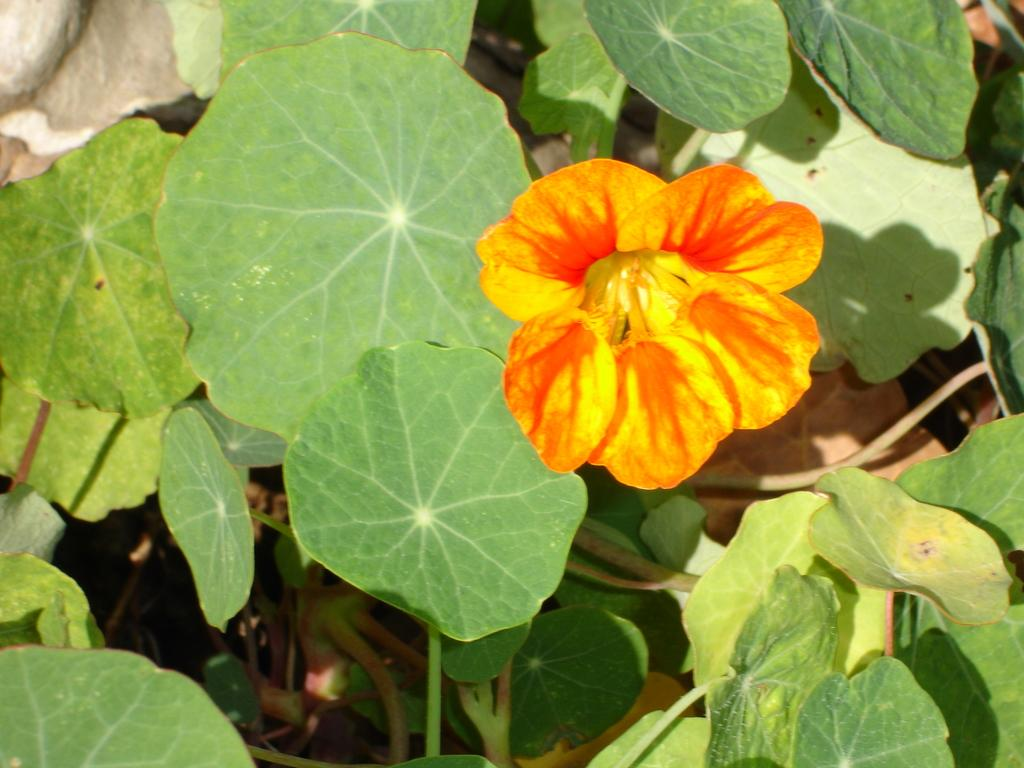What type of plant can be seen in the image? There is a flower in the image. What else is visible in the image besides the flower? There are leaves in the image. What type of door can be seen in the image? There is no door present in the image; it features a flower and leaves. What type of war is depicted in the image? There is no war depicted in the image; it features a flower and leaves. 